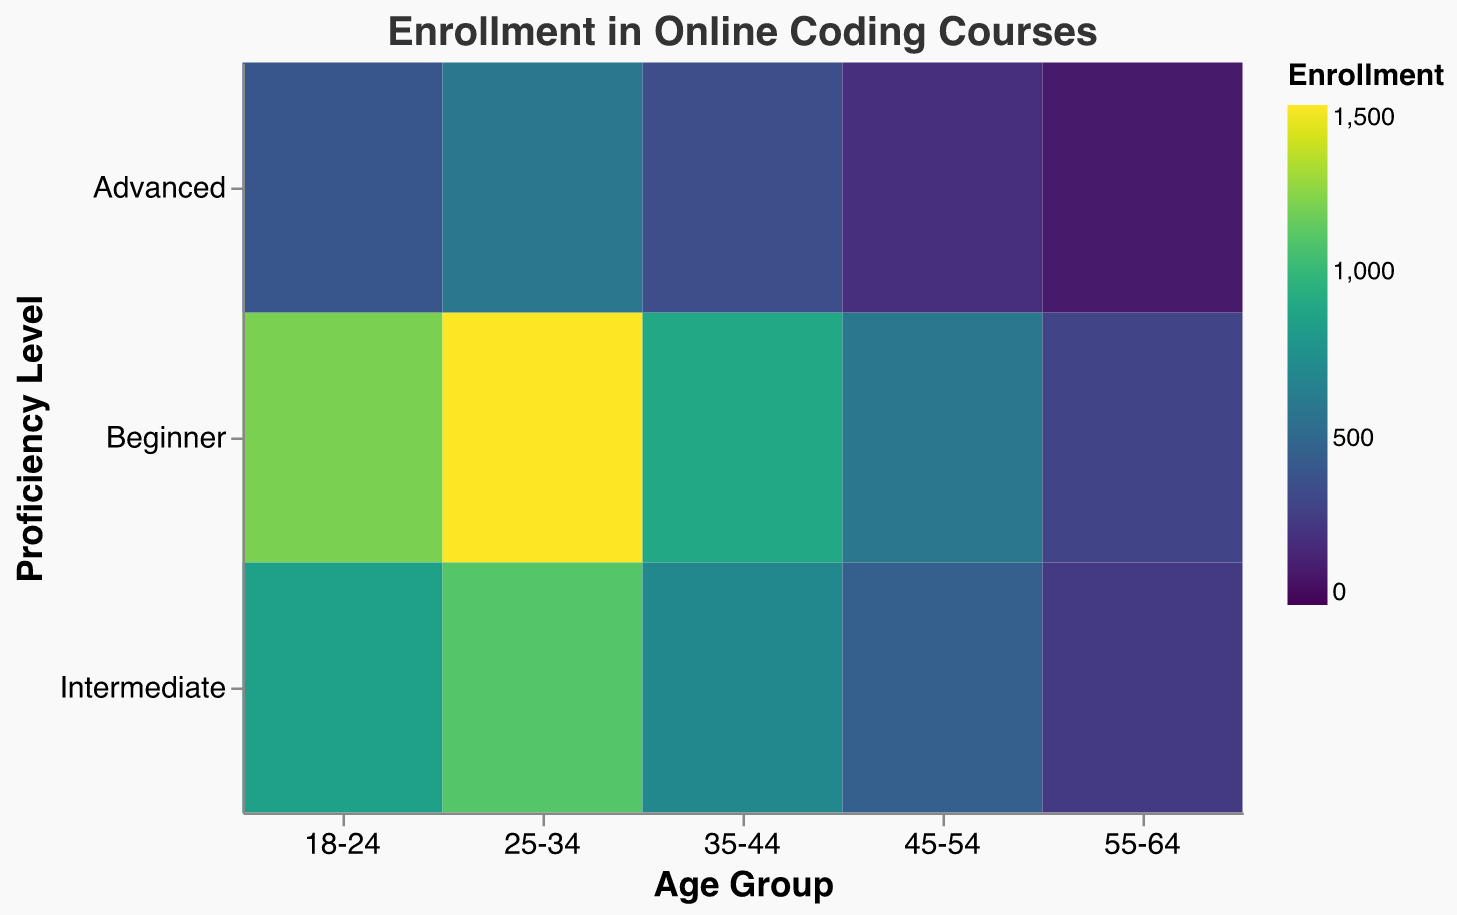What's the title of the figure? The title of the figure is located at the top of the chart. It reads "Enrollment in Online Coding Courses", indicating the subject of the visualization.
Answer: Enrollment in Online Coding Courses What are the labels for the x-axis and y-axis? The x-axis represents "Age Group" and the y-axis represents "Proficiency Level". These labels help identify the categories being analyzed in the heatmap.
Answer: Age Group, Proficiency Level How many age groups are depicted in the heatmap? The x-axis shows different age groups. By counting them, we find there are five age groups represented: "18-24", "25-34", "35-44", "45-54", and "55-64".
Answer: Five Which age group has the highest enrollment for beginner proficiency? By looking for the darkest color in the "Beginner" row, the age group "25-34" has the highest enrollment for beginners.
Answer: 25-34 Compare the enrollments for advanced proficiency between age groups 18-24 and 55-64. The data for advanced proficiency shows 400 enrollments for age group 18-24 and 100 for age group 55-64. By comparing these, 18-24 has more enrollments.
Answer: 18-24 has more enrollments (400 vs 100) Which proficiency level shows the smallest difference in enrollment across all age groups? Reviewing the color gradient in the heatmap, "Advanced" proficiency has smaller changes in darkness compared to "Beginner" and "Intermediate". Hence, the smallest difference is in "Advanced" proficiency.
Answer: Advanced Calculate the total enrollment for the age group 35-44 across all proficiency levels. Sum the enrollments: Beginner (900) + Intermediate (700) + Advanced (350) = 1950.
Answer: 1950 If we combine the intermediate and advanced enrollments for the age group 25-34, what is the total? Add the enrollments for Intermediate (1100) and Advanced (600): 1100 + 600 = 1700.
Answer: 1700 Which proficiency level has the highest enrollment for the age group 45-54? By checking the colors in the "45-54" column, "Beginner" has the darkest hue indicating the highest enrollment.
Answer: Beginner What trends can be observed in enrollment as age increases for intermediate proficiency? Observing the intermediate row from left to right, as age groups increase, enrollments consistently decrease from 850 (age 18-24) to 250 (age 55-64).
Answer: Enrollment decreases as age increases 